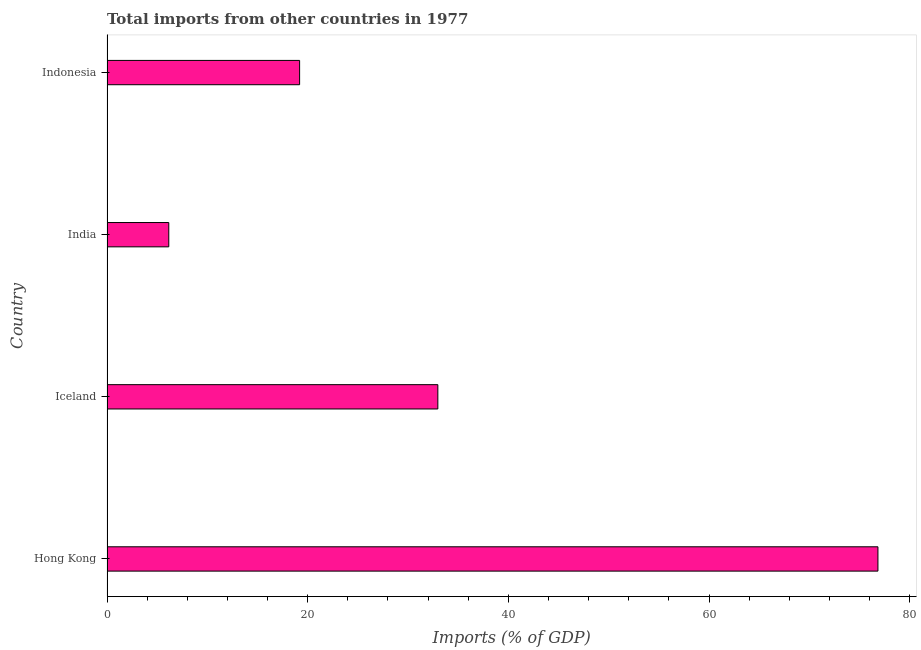Does the graph contain any zero values?
Your answer should be very brief. No. What is the title of the graph?
Offer a terse response. Total imports from other countries in 1977. What is the label or title of the X-axis?
Give a very brief answer. Imports (% of GDP). What is the label or title of the Y-axis?
Your answer should be very brief. Country. What is the total imports in Hong Kong?
Your answer should be very brief. 76.83. Across all countries, what is the maximum total imports?
Give a very brief answer. 76.83. Across all countries, what is the minimum total imports?
Your answer should be very brief. 6.16. In which country was the total imports maximum?
Provide a succinct answer. Hong Kong. What is the sum of the total imports?
Your response must be concise. 135.15. What is the difference between the total imports in Iceland and India?
Offer a very short reply. 26.81. What is the average total imports per country?
Keep it short and to the point. 33.79. What is the median total imports?
Ensure brevity in your answer.  26.08. What is the ratio of the total imports in Hong Kong to that in Iceland?
Offer a terse response. 2.33. Is the total imports in Iceland less than that in Indonesia?
Offer a terse response. No. Is the difference between the total imports in India and Indonesia greater than the difference between any two countries?
Your response must be concise. No. What is the difference between the highest and the second highest total imports?
Keep it short and to the point. 43.86. What is the difference between the highest and the lowest total imports?
Ensure brevity in your answer.  70.67. In how many countries, is the total imports greater than the average total imports taken over all countries?
Your response must be concise. 1. How many bars are there?
Provide a short and direct response. 4. What is the difference between two consecutive major ticks on the X-axis?
Provide a short and direct response. 20. Are the values on the major ticks of X-axis written in scientific E-notation?
Provide a succinct answer. No. What is the Imports (% of GDP) of Hong Kong?
Offer a terse response. 76.83. What is the Imports (% of GDP) of Iceland?
Provide a succinct answer. 32.97. What is the Imports (% of GDP) in India?
Your response must be concise. 6.16. What is the Imports (% of GDP) in Indonesia?
Make the answer very short. 19.19. What is the difference between the Imports (% of GDP) in Hong Kong and Iceland?
Ensure brevity in your answer.  43.86. What is the difference between the Imports (% of GDP) in Hong Kong and India?
Provide a succinct answer. 70.67. What is the difference between the Imports (% of GDP) in Hong Kong and Indonesia?
Offer a terse response. 57.63. What is the difference between the Imports (% of GDP) in Iceland and India?
Offer a very short reply. 26.81. What is the difference between the Imports (% of GDP) in Iceland and Indonesia?
Make the answer very short. 13.78. What is the difference between the Imports (% of GDP) in India and Indonesia?
Your answer should be compact. -13.04. What is the ratio of the Imports (% of GDP) in Hong Kong to that in Iceland?
Ensure brevity in your answer.  2.33. What is the ratio of the Imports (% of GDP) in Hong Kong to that in India?
Your answer should be very brief. 12.48. What is the ratio of the Imports (% of GDP) in Hong Kong to that in Indonesia?
Your answer should be compact. 4. What is the ratio of the Imports (% of GDP) in Iceland to that in India?
Offer a very short reply. 5.36. What is the ratio of the Imports (% of GDP) in Iceland to that in Indonesia?
Your response must be concise. 1.72. What is the ratio of the Imports (% of GDP) in India to that in Indonesia?
Make the answer very short. 0.32. 